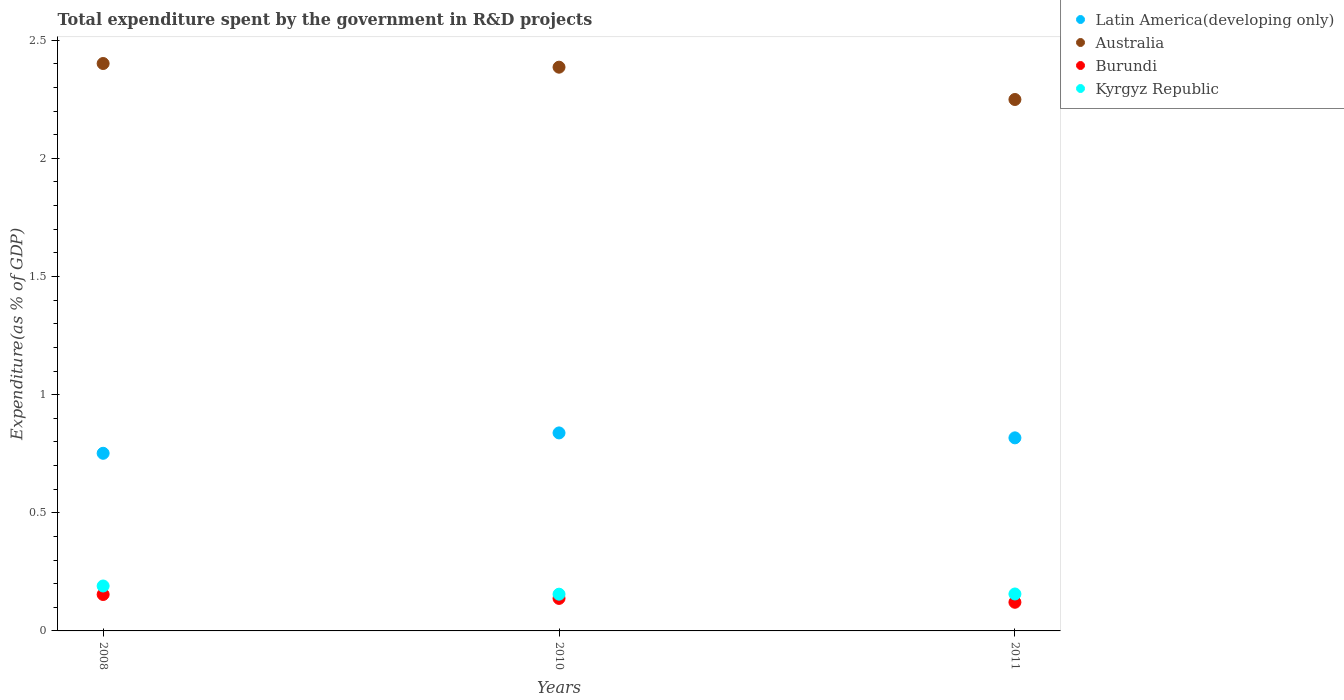What is the total expenditure spent by the government in R&D projects in Latin America(developing only) in 2008?
Your answer should be compact. 0.75. Across all years, what is the maximum total expenditure spent by the government in R&D projects in Kyrgyz Republic?
Provide a short and direct response. 0.19. Across all years, what is the minimum total expenditure spent by the government in R&D projects in Kyrgyz Republic?
Your response must be concise. 0.16. In which year was the total expenditure spent by the government in R&D projects in Australia maximum?
Your answer should be compact. 2008. What is the total total expenditure spent by the government in R&D projects in Australia in the graph?
Give a very brief answer. 7.04. What is the difference between the total expenditure spent by the government in R&D projects in Latin America(developing only) in 2010 and that in 2011?
Provide a short and direct response. 0.02. What is the difference between the total expenditure spent by the government in R&D projects in Australia in 2011 and the total expenditure spent by the government in R&D projects in Kyrgyz Republic in 2010?
Offer a terse response. 2.09. What is the average total expenditure spent by the government in R&D projects in Australia per year?
Provide a succinct answer. 2.35. In the year 2010, what is the difference between the total expenditure spent by the government in R&D projects in Latin America(developing only) and total expenditure spent by the government in R&D projects in Burundi?
Keep it short and to the point. 0.7. What is the ratio of the total expenditure spent by the government in R&D projects in Kyrgyz Republic in 2008 to that in 2011?
Make the answer very short. 1.22. Is the total expenditure spent by the government in R&D projects in Kyrgyz Republic in 2008 less than that in 2011?
Keep it short and to the point. No. What is the difference between the highest and the second highest total expenditure spent by the government in R&D projects in Latin America(developing only)?
Provide a succinct answer. 0.02. What is the difference between the highest and the lowest total expenditure spent by the government in R&D projects in Latin America(developing only)?
Give a very brief answer. 0.09. In how many years, is the total expenditure spent by the government in R&D projects in Australia greater than the average total expenditure spent by the government in R&D projects in Australia taken over all years?
Your answer should be compact. 2. Is the sum of the total expenditure spent by the government in R&D projects in Australia in 2010 and 2011 greater than the maximum total expenditure spent by the government in R&D projects in Latin America(developing only) across all years?
Keep it short and to the point. Yes. Is it the case that in every year, the sum of the total expenditure spent by the government in R&D projects in Burundi and total expenditure spent by the government in R&D projects in Australia  is greater than the sum of total expenditure spent by the government in R&D projects in Kyrgyz Republic and total expenditure spent by the government in R&D projects in Latin America(developing only)?
Your answer should be very brief. Yes. Is it the case that in every year, the sum of the total expenditure spent by the government in R&D projects in Australia and total expenditure spent by the government in R&D projects in Burundi  is greater than the total expenditure spent by the government in R&D projects in Kyrgyz Republic?
Provide a succinct answer. Yes. Are the values on the major ticks of Y-axis written in scientific E-notation?
Give a very brief answer. No. Does the graph contain grids?
Give a very brief answer. No. What is the title of the graph?
Provide a succinct answer. Total expenditure spent by the government in R&D projects. Does "Turkey" appear as one of the legend labels in the graph?
Provide a short and direct response. No. What is the label or title of the Y-axis?
Offer a very short reply. Expenditure(as % of GDP). What is the Expenditure(as % of GDP) in Latin America(developing only) in 2008?
Offer a terse response. 0.75. What is the Expenditure(as % of GDP) in Australia in 2008?
Your answer should be compact. 2.4. What is the Expenditure(as % of GDP) in Burundi in 2008?
Your response must be concise. 0.15. What is the Expenditure(as % of GDP) in Kyrgyz Republic in 2008?
Offer a very short reply. 0.19. What is the Expenditure(as % of GDP) in Latin America(developing only) in 2010?
Provide a succinct answer. 0.84. What is the Expenditure(as % of GDP) in Australia in 2010?
Your response must be concise. 2.39. What is the Expenditure(as % of GDP) of Burundi in 2010?
Your answer should be very brief. 0.14. What is the Expenditure(as % of GDP) of Kyrgyz Republic in 2010?
Offer a terse response. 0.16. What is the Expenditure(as % of GDP) in Latin America(developing only) in 2011?
Your answer should be compact. 0.82. What is the Expenditure(as % of GDP) in Australia in 2011?
Make the answer very short. 2.25. What is the Expenditure(as % of GDP) in Burundi in 2011?
Your answer should be very brief. 0.12. What is the Expenditure(as % of GDP) of Kyrgyz Republic in 2011?
Make the answer very short. 0.16. Across all years, what is the maximum Expenditure(as % of GDP) in Latin America(developing only)?
Offer a terse response. 0.84. Across all years, what is the maximum Expenditure(as % of GDP) in Australia?
Your answer should be very brief. 2.4. Across all years, what is the maximum Expenditure(as % of GDP) of Burundi?
Keep it short and to the point. 0.15. Across all years, what is the maximum Expenditure(as % of GDP) in Kyrgyz Republic?
Provide a short and direct response. 0.19. Across all years, what is the minimum Expenditure(as % of GDP) in Latin America(developing only)?
Your answer should be very brief. 0.75. Across all years, what is the minimum Expenditure(as % of GDP) of Australia?
Offer a very short reply. 2.25. Across all years, what is the minimum Expenditure(as % of GDP) in Burundi?
Keep it short and to the point. 0.12. Across all years, what is the minimum Expenditure(as % of GDP) of Kyrgyz Republic?
Offer a very short reply. 0.16. What is the total Expenditure(as % of GDP) of Latin America(developing only) in the graph?
Ensure brevity in your answer.  2.41. What is the total Expenditure(as % of GDP) in Australia in the graph?
Your answer should be compact. 7.04. What is the total Expenditure(as % of GDP) in Burundi in the graph?
Your answer should be very brief. 0.41. What is the total Expenditure(as % of GDP) in Kyrgyz Republic in the graph?
Offer a terse response. 0.5. What is the difference between the Expenditure(as % of GDP) of Latin America(developing only) in 2008 and that in 2010?
Your response must be concise. -0.09. What is the difference between the Expenditure(as % of GDP) of Australia in 2008 and that in 2010?
Your answer should be very brief. 0.02. What is the difference between the Expenditure(as % of GDP) of Burundi in 2008 and that in 2010?
Your answer should be compact. 0.02. What is the difference between the Expenditure(as % of GDP) in Kyrgyz Republic in 2008 and that in 2010?
Provide a succinct answer. 0.03. What is the difference between the Expenditure(as % of GDP) in Latin America(developing only) in 2008 and that in 2011?
Provide a short and direct response. -0.07. What is the difference between the Expenditure(as % of GDP) in Australia in 2008 and that in 2011?
Your answer should be very brief. 0.15. What is the difference between the Expenditure(as % of GDP) in Burundi in 2008 and that in 2011?
Your answer should be compact. 0.03. What is the difference between the Expenditure(as % of GDP) in Kyrgyz Republic in 2008 and that in 2011?
Your response must be concise. 0.03. What is the difference between the Expenditure(as % of GDP) of Latin America(developing only) in 2010 and that in 2011?
Keep it short and to the point. 0.02. What is the difference between the Expenditure(as % of GDP) of Australia in 2010 and that in 2011?
Your answer should be very brief. 0.14. What is the difference between the Expenditure(as % of GDP) of Burundi in 2010 and that in 2011?
Offer a very short reply. 0.02. What is the difference between the Expenditure(as % of GDP) of Kyrgyz Republic in 2010 and that in 2011?
Your response must be concise. -0. What is the difference between the Expenditure(as % of GDP) of Latin America(developing only) in 2008 and the Expenditure(as % of GDP) of Australia in 2010?
Your response must be concise. -1.63. What is the difference between the Expenditure(as % of GDP) of Latin America(developing only) in 2008 and the Expenditure(as % of GDP) of Burundi in 2010?
Your answer should be compact. 0.61. What is the difference between the Expenditure(as % of GDP) in Latin America(developing only) in 2008 and the Expenditure(as % of GDP) in Kyrgyz Republic in 2010?
Provide a short and direct response. 0.6. What is the difference between the Expenditure(as % of GDP) of Australia in 2008 and the Expenditure(as % of GDP) of Burundi in 2010?
Give a very brief answer. 2.26. What is the difference between the Expenditure(as % of GDP) in Australia in 2008 and the Expenditure(as % of GDP) in Kyrgyz Republic in 2010?
Give a very brief answer. 2.25. What is the difference between the Expenditure(as % of GDP) of Burundi in 2008 and the Expenditure(as % of GDP) of Kyrgyz Republic in 2010?
Keep it short and to the point. -0. What is the difference between the Expenditure(as % of GDP) in Latin America(developing only) in 2008 and the Expenditure(as % of GDP) in Australia in 2011?
Your response must be concise. -1.5. What is the difference between the Expenditure(as % of GDP) of Latin America(developing only) in 2008 and the Expenditure(as % of GDP) of Burundi in 2011?
Your response must be concise. 0.63. What is the difference between the Expenditure(as % of GDP) of Latin America(developing only) in 2008 and the Expenditure(as % of GDP) of Kyrgyz Republic in 2011?
Provide a succinct answer. 0.6. What is the difference between the Expenditure(as % of GDP) in Australia in 2008 and the Expenditure(as % of GDP) in Burundi in 2011?
Offer a terse response. 2.28. What is the difference between the Expenditure(as % of GDP) of Australia in 2008 and the Expenditure(as % of GDP) of Kyrgyz Republic in 2011?
Provide a succinct answer. 2.25. What is the difference between the Expenditure(as % of GDP) of Burundi in 2008 and the Expenditure(as % of GDP) of Kyrgyz Republic in 2011?
Your answer should be compact. -0. What is the difference between the Expenditure(as % of GDP) in Latin America(developing only) in 2010 and the Expenditure(as % of GDP) in Australia in 2011?
Offer a very short reply. -1.41. What is the difference between the Expenditure(as % of GDP) of Latin America(developing only) in 2010 and the Expenditure(as % of GDP) of Burundi in 2011?
Provide a succinct answer. 0.72. What is the difference between the Expenditure(as % of GDP) in Latin America(developing only) in 2010 and the Expenditure(as % of GDP) in Kyrgyz Republic in 2011?
Keep it short and to the point. 0.68. What is the difference between the Expenditure(as % of GDP) in Australia in 2010 and the Expenditure(as % of GDP) in Burundi in 2011?
Your answer should be compact. 2.26. What is the difference between the Expenditure(as % of GDP) in Australia in 2010 and the Expenditure(as % of GDP) in Kyrgyz Republic in 2011?
Ensure brevity in your answer.  2.23. What is the difference between the Expenditure(as % of GDP) of Burundi in 2010 and the Expenditure(as % of GDP) of Kyrgyz Republic in 2011?
Provide a succinct answer. -0.02. What is the average Expenditure(as % of GDP) of Latin America(developing only) per year?
Provide a succinct answer. 0.8. What is the average Expenditure(as % of GDP) of Australia per year?
Your answer should be very brief. 2.35. What is the average Expenditure(as % of GDP) in Burundi per year?
Keep it short and to the point. 0.14. What is the average Expenditure(as % of GDP) of Kyrgyz Republic per year?
Provide a short and direct response. 0.17. In the year 2008, what is the difference between the Expenditure(as % of GDP) of Latin America(developing only) and Expenditure(as % of GDP) of Australia?
Give a very brief answer. -1.65. In the year 2008, what is the difference between the Expenditure(as % of GDP) of Latin America(developing only) and Expenditure(as % of GDP) of Burundi?
Make the answer very short. 0.6. In the year 2008, what is the difference between the Expenditure(as % of GDP) of Latin America(developing only) and Expenditure(as % of GDP) of Kyrgyz Republic?
Ensure brevity in your answer.  0.56. In the year 2008, what is the difference between the Expenditure(as % of GDP) in Australia and Expenditure(as % of GDP) in Burundi?
Make the answer very short. 2.25. In the year 2008, what is the difference between the Expenditure(as % of GDP) in Australia and Expenditure(as % of GDP) in Kyrgyz Republic?
Ensure brevity in your answer.  2.21. In the year 2008, what is the difference between the Expenditure(as % of GDP) in Burundi and Expenditure(as % of GDP) in Kyrgyz Republic?
Provide a short and direct response. -0.04. In the year 2010, what is the difference between the Expenditure(as % of GDP) in Latin America(developing only) and Expenditure(as % of GDP) in Australia?
Your answer should be very brief. -1.55. In the year 2010, what is the difference between the Expenditure(as % of GDP) in Latin America(developing only) and Expenditure(as % of GDP) in Burundi?
Ensure brevity in your answer.  0.7. In the year 2010, what is the difference between the Expenditure(as % of GDP) in Latin America(developing only) and Expenditure(as % of GDP) in Kyrgyz Republic?
Your answer should be compact. 0.68. In the year 2010, what is the difference between the Expenditure(as % of GDP) in Australia and Expenditure(as % of GDP) in Burundi?
Your answer should be compact. 2.25. In the year 2010, what is the difference between the Expenditure(as % of GDP) in Australia and Expenditure(as % of GDP) in Kyrgyz Republic?
Provide a succinct answer. 2.23. In the year 2010, what is the difference between the Expenditure(as % of GDP) of Burundi and Expenditure(as % of GDP) of Kyrgyz Republic?
Offer a terse response. -0.02. In the year 2011, what is the difference between the Expenditure(as % of GDP) of Latin America(developing only) and Expenditure(as % of GDP) of Australia?
Ensure brevity in your answer.  -1.43. In the year 2011, what is the difference between the Expenditure(as % of GDP) of Latin America(developing only) and Expenditure(as % of GDP) of Burundi?
Provide a short and direct response. 0.7. In the year 2011, what is the difference between the Expenditure(as % of GDP) in Latin America(developing only) and Expenditure(as % of GDP) in Kyrgyz Republic?
Offer a very short reply. 0.66. In the year 2011, what is the difference between the Expenditure(as % of GDP) of Australia and Expenditure(as % of GDP) of Burundi?
Provide a succinct answer. 2.13. In the year 2011, what is the difference between the Expenditure(as % of GDP) of Australia and Expenditure(as % of GDP) of Kyrgyz Republic?
Give a very brief answer. 2.09. In the year 2011, what is the difference between the Expenditure(as % of GDP) in Burundi and Expenditure(as % of GDP) in Kyrgyz Republic?
Provide a succinct answer. -0.04. What is the ratio of the Expenditure(as % of GDP) in Latin America(developing only) in 2008 to that in 2010?
Your answer should be compact. 0.9. What is the ratio of the Expenditure(as % of GDP) of Burundi in 2008 to that in 2010?
Provide a short and direct response. 1.12. What is the ratio of the Expenditure(as % of GDP) in Kyrgyz Republic in 2008 to that in 2010?
Your answer should be compact. 1.22. What is the ratio of the Expenditure(as % of GDP) of Latin America(developing only) in 2008 to that in 2011?
Keep it short and to the point. 0.92. What is the ratio of the Expenditure(as % of GDP) of Australia in 2008 to that in 2011?
Your answer should be compact. 1.07. What is the ratio of the Expenditure(as % of GDP) in Burundi in 2008 to that in 2011?
Your answer should be compact. 1.27. What is the ratio of the Expenditure(as % of GDP) of Kyrgyz Republic in 2008 to that in 2011?
Provide a succinct answer. 1.22. What is the ratio of the Expenditure(as % of GDP) in Latin America(developing only) in 2010 to that in 2011?
Provide a short and direct response. 1.03. What is the ratio of the Expenditure(as % of GDP) in Australia in 2010 to that in 2011?
Offer a terse response. 1.06. What is the ratio of the Expenditure(as % of GDP) of Burundi in 2010 to that in 2011?
Offer a very short reply. 1.13. What is the difference between the highest and the second highest Expenditure(as % of GDP) of Latin America(developing only)?
Your response must be concise. 0.02. What is the difference between the highest and the second highest Expenditure(as % of GDP) in Australia?
Give a very brief answer. 0.02. What is the difference between the highest and the second highest Expenditure(as % of GDP) of Burundi?
Your answer should be compact. 0.02. What is the difference between the highest and the second highest Expenditure(as % of GDP) in Kyrgyz Republic?
Your answer should be very brief. 0.03. What is the difference between the highest and the lowest Expenditure(as % of GDP) of Latin America(developing only)?
Provide a succinct answer. 0.09. What is the difference between the highest and the lowest Expenditure(as % of GDP) of Australia?
Offer a terse response. 0.15. What is the difference between the highest and the lowest Expenditure(as % of GDP) of Burundi?
Give a very brief answer. 0.03. What is the difference between the highest and the lowest Expenditure(as % of GDP) of Kyrgyz Republic?
Give a very brief answer. 0.03. 